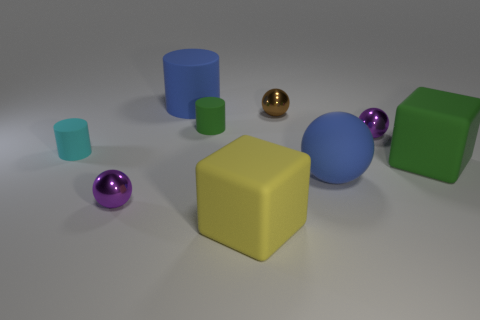There is a purple thing behind the purple sphere that is on the left side of the big yellow rubber cube; what is its material?
Give a very brief answer. Metal. What is the shape of the tiny object that is in front of the green matte cylinder and right of the yellow thing?
Provide a succinct answer. Sphere. There is a matte thing that is the same shape as the brown metal thing; what size is it?
Offer a terse response. Large. Are there fewer small brown objects in front of the green block than large balls?
Provide a short and direct response. Yes. There is a blue thing to the right of the blue cylinder; how big is it?
Your answer should be very brief. Large. There is another rubber thing that is the same shape as the big yellow object; what is its color?
Your response must be concise. Green. How many other large rubber spheres have the same color as the large rubber ball?
Your answer should be very brief. 0. Is there any other thing that is the same shape as the small green matte thing?
Your response must be concise. Yes. Is there a brown object that is on the right side of the tiny purple metallic object that is behind the metal object left of the big yellow rubber block?
Your response must be concise. No. How many cyan objects have the same material as the large sphere?
Make the answer very short. 1. 